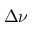Convert formula to latex. <formula><loc_0><loc_0><loc_500><loc_500>\Delta \nu</formula> 